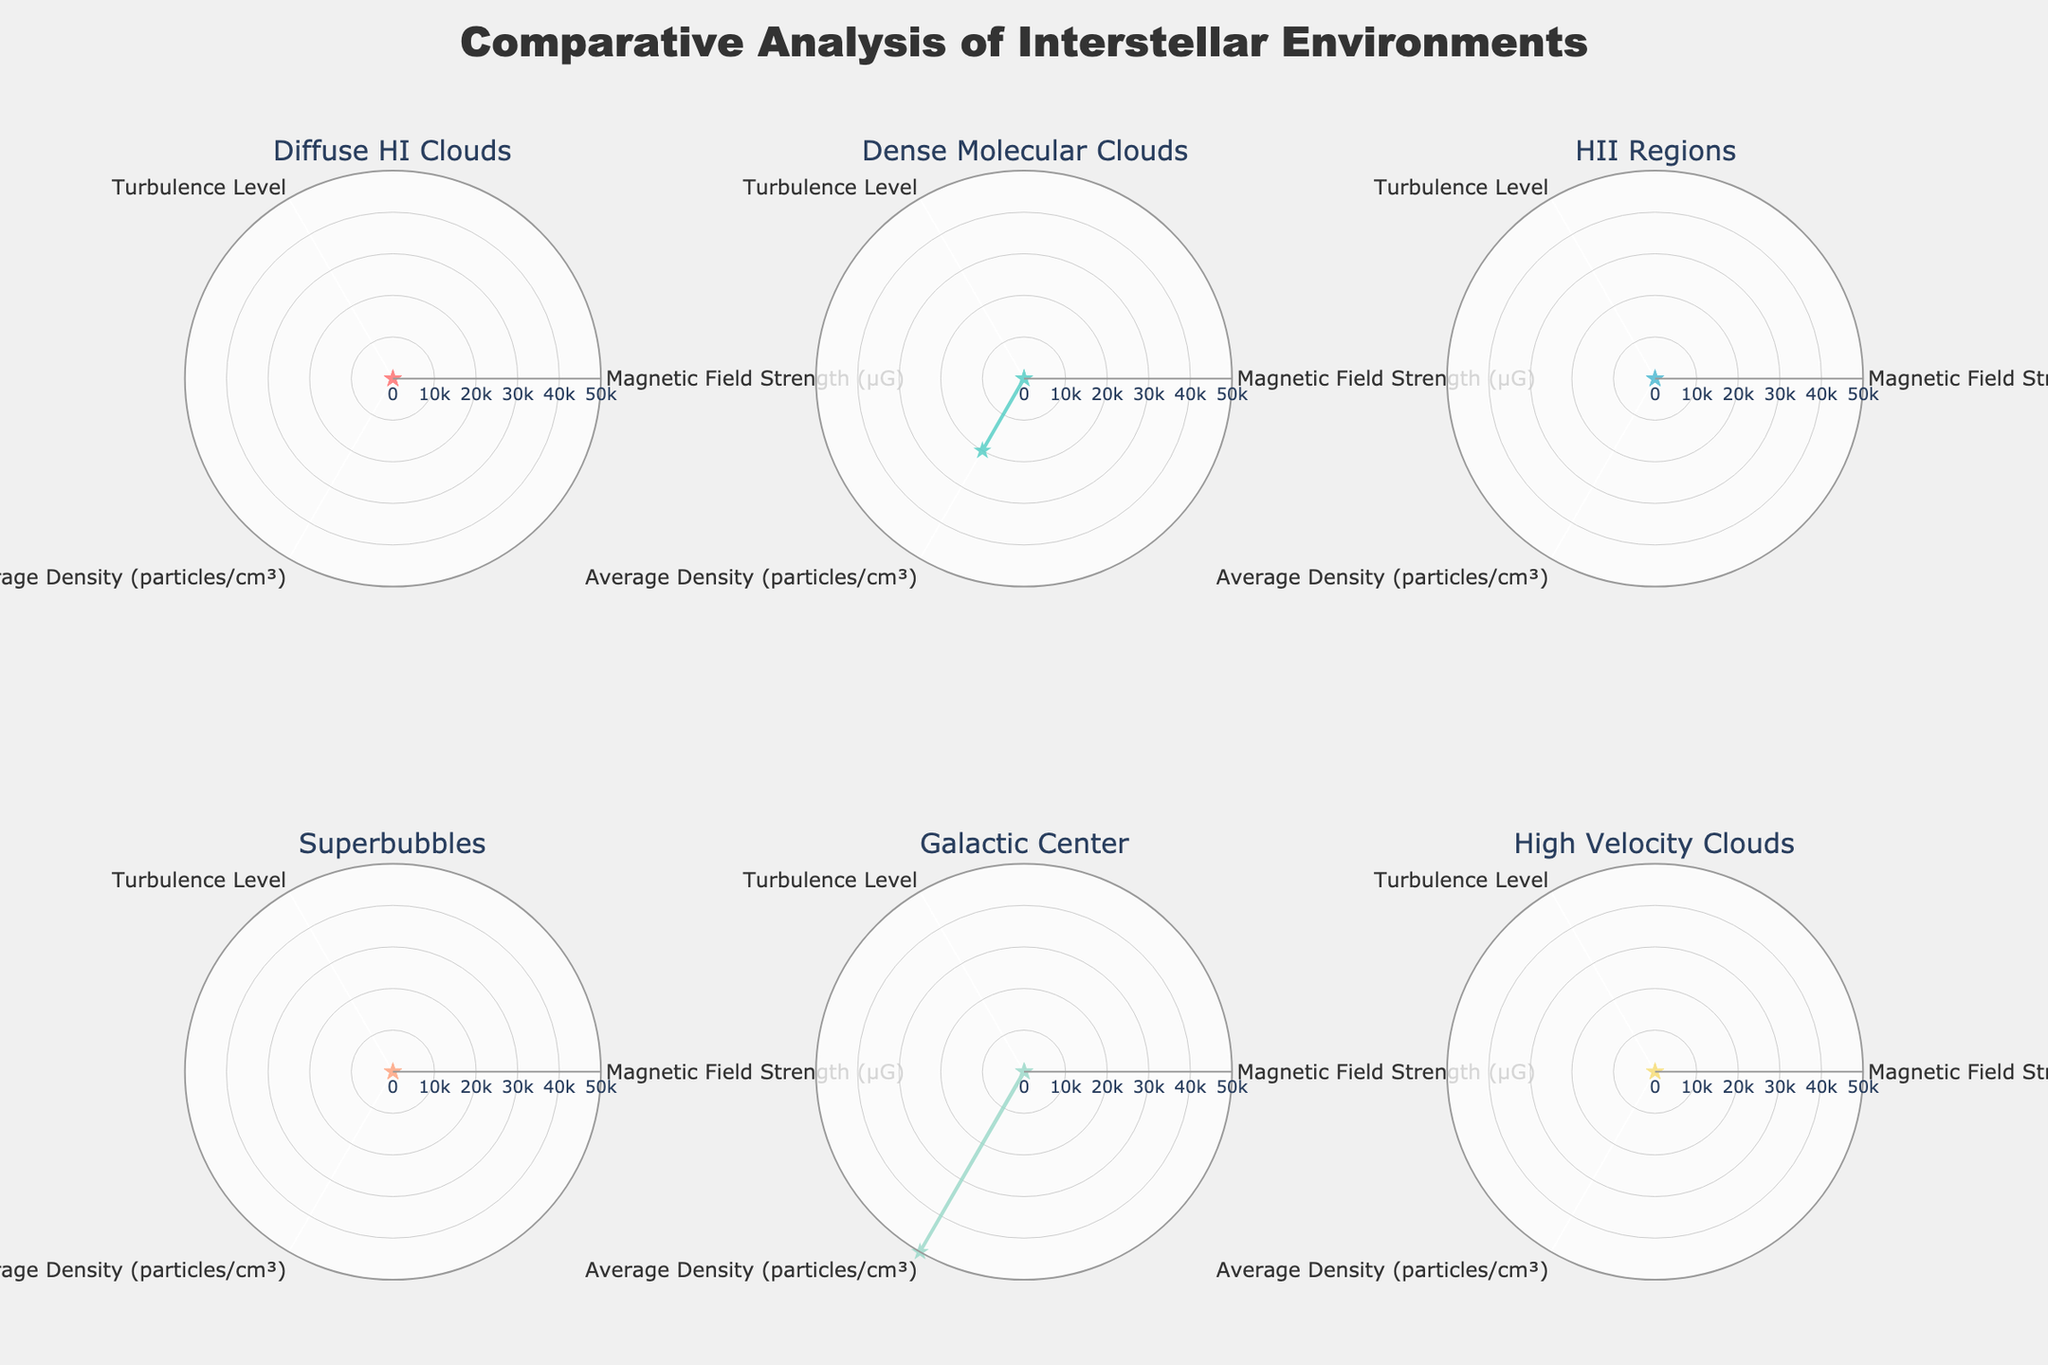Which environment has the highest magnetic field strength? By looking at the radar chart subplot titles, each representing different interstellar environments, and examining the value for 'Magnetic Field Strength (µG)', we can see that the Galactic Center has the highest value.
Answer: Galactic Center How does the turbulence level in the Superbubbles compare to that in High Velocity Clouds? By examining the radar charts for 'Turbulence Level' for both Superbubbles and High Velocity Clouds, we can see that Superbubbles have a turbulence level of 25, while High Velocity Clouds have a turbulence level of 8. Therefore, Superbubbles have a higher turbulence level.
Answer: Superbubbles have a higher turbulence level Which environment has the lowest average density? By checking the 'Average Density (particles/cm³)' values across all radar charts, we find that Superbubbles have the lowest average density with a value of 10.
Answer: Superbubbles What is the difference in magnetic field strength between Dense Molecular Clouds and Diffuse HI Clouds? For Dense Molecular Clouds, the 'Magnetic Field Strength (µG)' is 25 and for Diffuse HI Clouds, it is 5. The difference is calculated as 25 - 5 = 20.
Answer: 20 Which environments have a magnetic field strength greater than 10 µG? By reviewing the radar charts for 'Magnetic Field Strength (µG)', we see that Dense Molecular Clouds, HII Regions, Superbubbles, and Galactic Center have magnetic field strengths of 25, 10, 15, and 100 respectively. Therefore, Dense Molecular Clouds, Superbubbles, and Galactic Center are greater than 10 µG.
Answer: Dense Molecular Clouds, Superbubbles, Galactic Center What's the sum of average densities for Diffuse HI Clouds and HII Regions? For Diffuse HI Clouds, 'Average Density (particles/cm³)' is 50 and for HII Regions, it is 80. The sum is calculated as 50 + 80 = 130.
Answer: 130 Which environment has the highest turbulence level and what is that value? Checking the radar charts for 'Turbulence Level', the Galactic Center shows the highest value with a level of 60.
Answer: Galactic Center, 60 How many environments have a turbulence level below 20? By looking at the radar charts, we see that Diffuse HI Clouds have a turbulence level of 10, and High Velocity Clouds have a turbulence level of 8. Therefore, two environments have a turbulence level below 20.
Answer: 2 